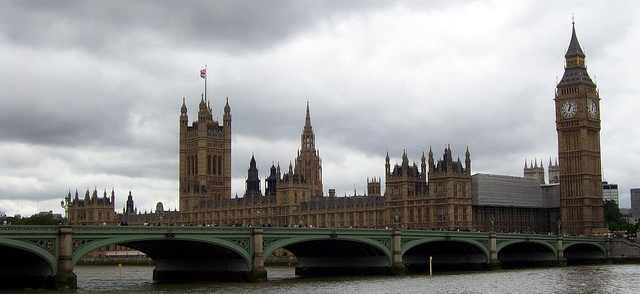Describe the objects in this image and their specific colors. I can see clock in darkgray, gray, and black tones and clock in darkgray, gray, and black tones in this image. 